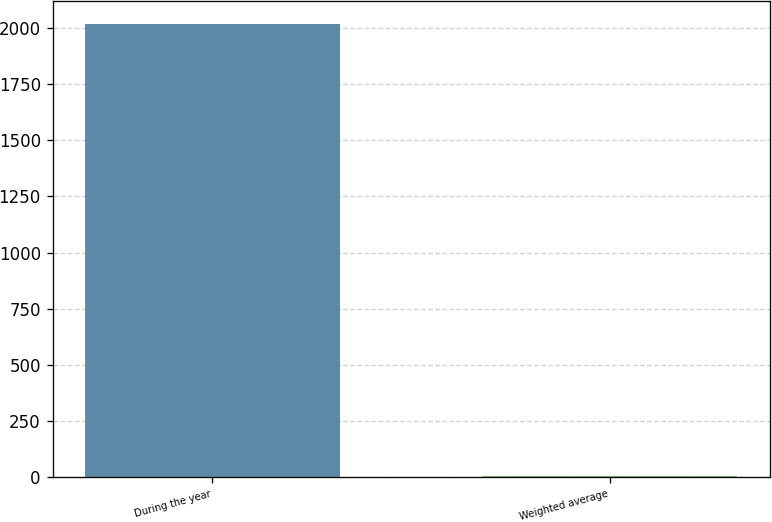Convert chart. <chart><loc_0><loc_0><loc_500><loc_500><bar_chart><fcel>During the year<fcel>Weighted average<nl><fcel>2016<fcel>4.76<nl></chart> 